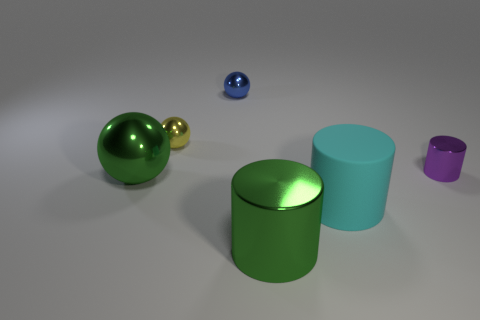Add 3 tiny yellow metal things. How many objects exist? 9 Add 6 blue metallic spheres. How many blue metallic spheres exist? 7 Subtract 0 gray cylinders. How many objects are left? 6 Subtract all large metal cylinders. Subtract all small blue metal balls. How many objects are left? 4 Add 2 matte objects. How many matte objects are left? 3 